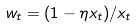Convert formula to latex. <formula><loc_0><loc_0><loc_500><loc_500>w _ { t } = ( 1 - \eta x _ { t } ) / x _ { t }</formula> 